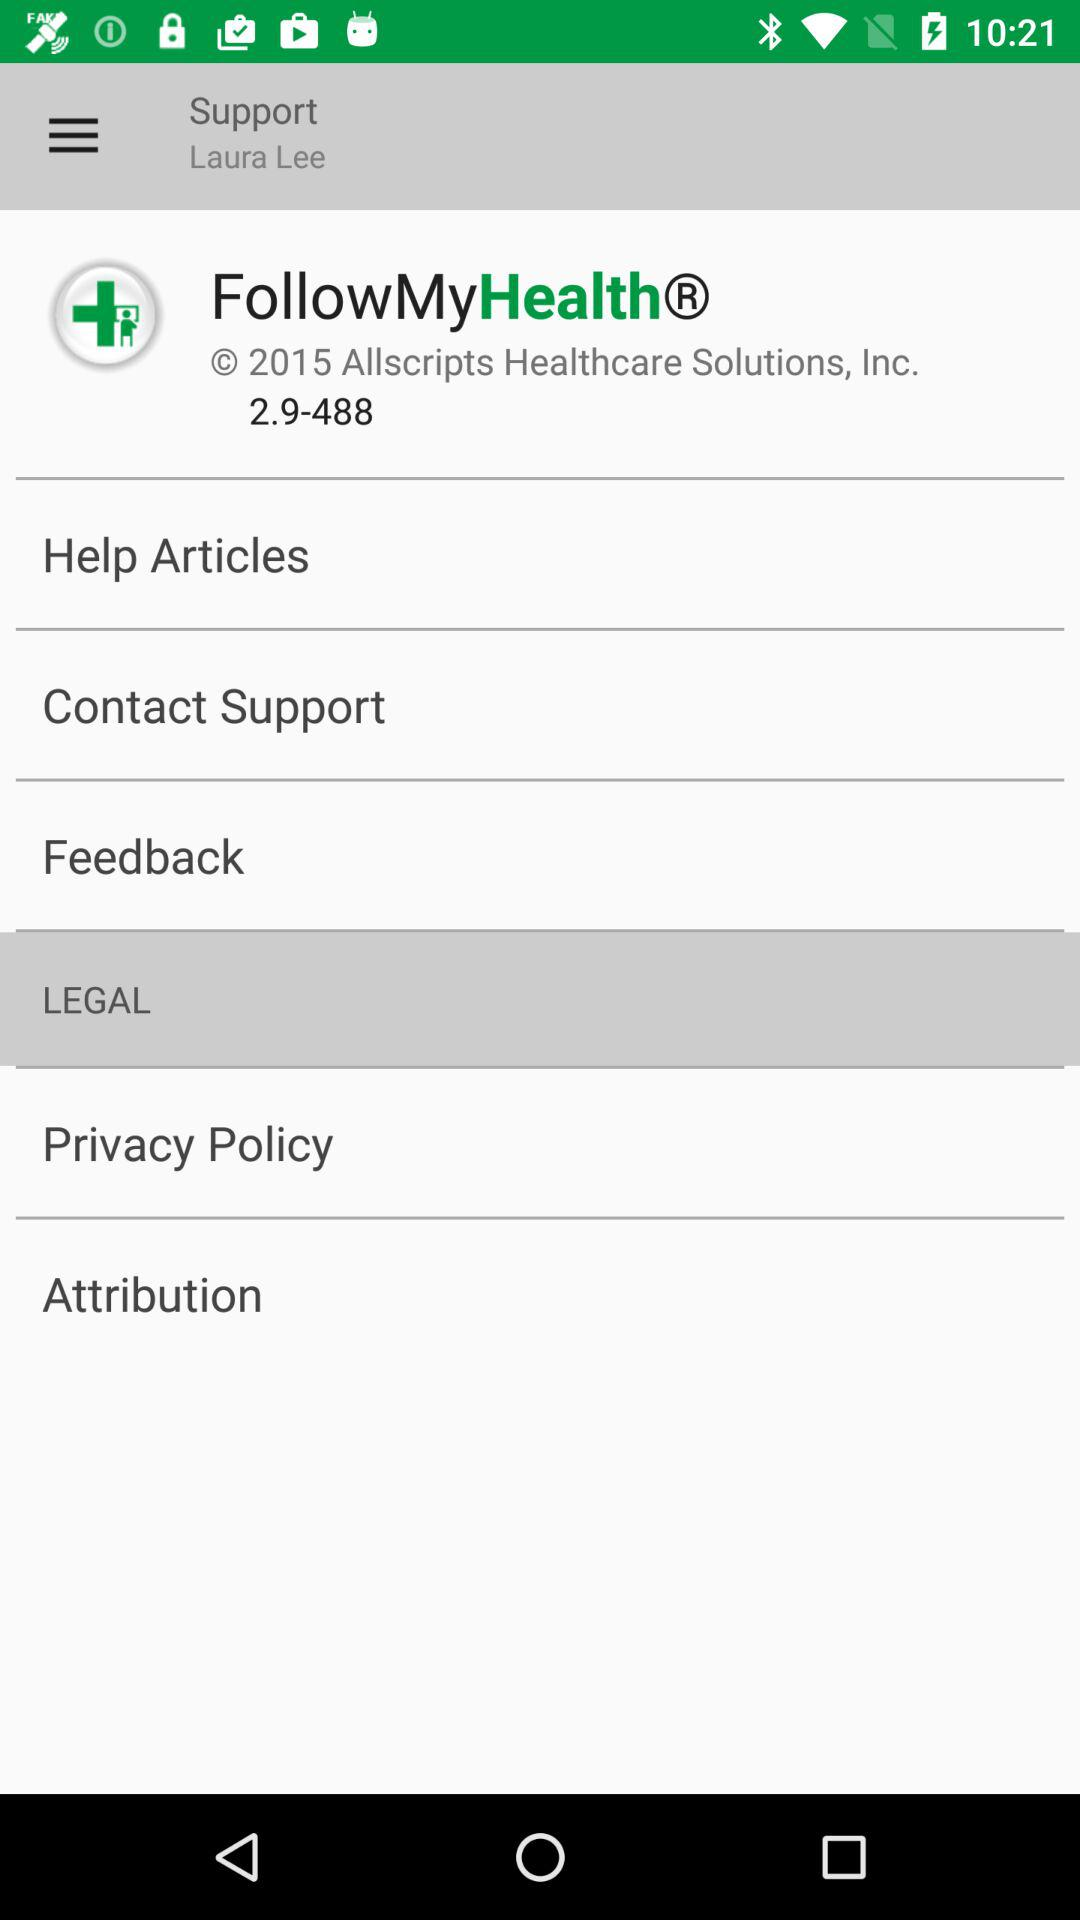What is the name of the application? The name of the application is "FollowMyHealth". 